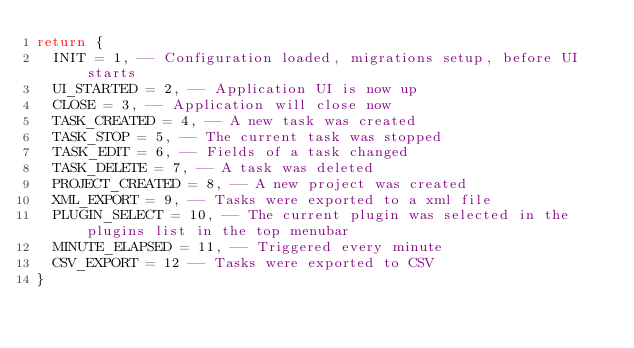Convert code to text. <code><loc_0><loc_0><loc_500><loc_500><_Lua_>return {
  INIT = 1, -- Configuration loaded, migrations setup, before UI starts
  UI_STARTED = 2, -- Application UI is now up
  CLOSE = 3, -- Application will close now
  TASK_CREATED = 4, -- A new task was created
  TASK_STOP = 5, -- The current task was stopped
  TASK_EDIT = 6, -- Fields of a task changed
  TASK_DELETE = 7, -- A task was deleted
  PROJECT_CREATED = 8, -- A new project was created
  XML_EXPORT = 9, -- Tasks were exported to a xml file
  PLUGIN_SELECT = 10, -- The current plugin was selected in the plugins list in the top menubar
  MINUTE_ELAPSED = 11, -- Triggered every minute
  CSV_EXPORT = 12 -- Tasks were exported to CSV
}
</code> 